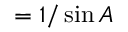Convert formula to latex. <formula><loc_0><loc_0><loc_500><loc_500>= { 1 / \sin A }</formula> 